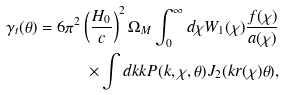Convert formula to latex. <formula><loc_0><loc_0><loc_500><loc_500>\gamma _ { t } ( \theta ) = 6 \pi ^ { 2 } \left ( \frac { H _ { 0 } } { c } \right ) ^ { 2 } \Omega _ { M } \int _ { 0 } ^ { \infty } d \chi W _ { 1 } ( \chi ) \frac { f ( \chi ) } { a ( \chi ) } \\ \times \int d k k P ( k , \chi , \theta ) J _ { 2 } ( k r ( \chi ) \theta ) ,</formula> 